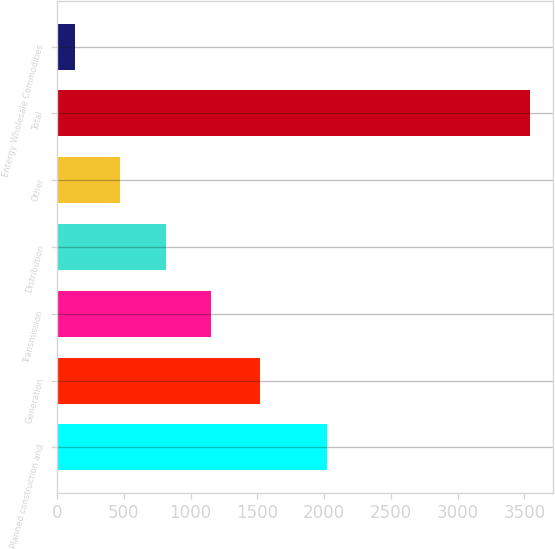Convert chart to OTSL. <chart><loc_0><loc_0><loc_500><loc_500><bar_chart><fcel>Planned construction and<fcel>Generation<fcel>Transmission<fcel>Distribution<fcel>Other<fcel>Total<fcel>Entergy Wholesale Commodities<nl><fcel>2018<fcel>1520<fcel>1153<fcel>812<fcel>471<fcel>3540<fcel>130<nl></chart> 